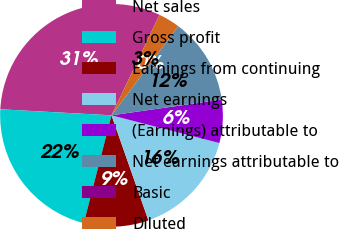Convert chart to OTSL. <chart><loc_0><loc_0><loc_500><loc_500><pie_chart><fcel>Net sales<fcel>Gross profit<fcel>Earnings from continuing<fcel>Net earnings<fcel>(Earnings) attributable to<fcel>Net earnings attributable to<fcel>Basic<fcel>Diluted<nl><fcel>31.23%<fcel>21.86%<fcel>9.38%<fcel>15.62%<fcel>6.26%<fcel>12.5%<fcel>0.01%<fcel>3.14%<nl></chart> 